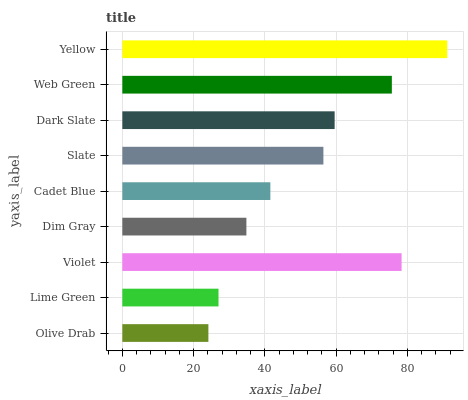Is Olive Drab the minimum?
Answer yes or no. Yes. Is Yellow the maximum?
Answer yes or no. Yes. Is Lime Green the minimum?
Answer yes or no. No. Is Lime Green the maximum?
Answer yes or no. No. Is Lime Green greater than Olive Drab?
Answer yes or no. Yes. Is Olive Drab less than Lime Green?
Answer yes or no. Yes. Is Olive Drab greater than Lime Green?
Answer yes or no. No. Is Lime Green less than Olive Drab?
Answer yes or no. No. Is Slate the high median?
Answer yes or no. Yes. Is Slate the low median?
Answer yes or no. Yes. Is Dark Slate the high median?
Answer yes or no. No. Is Web Green the low median?
Answer yes or no. No. 